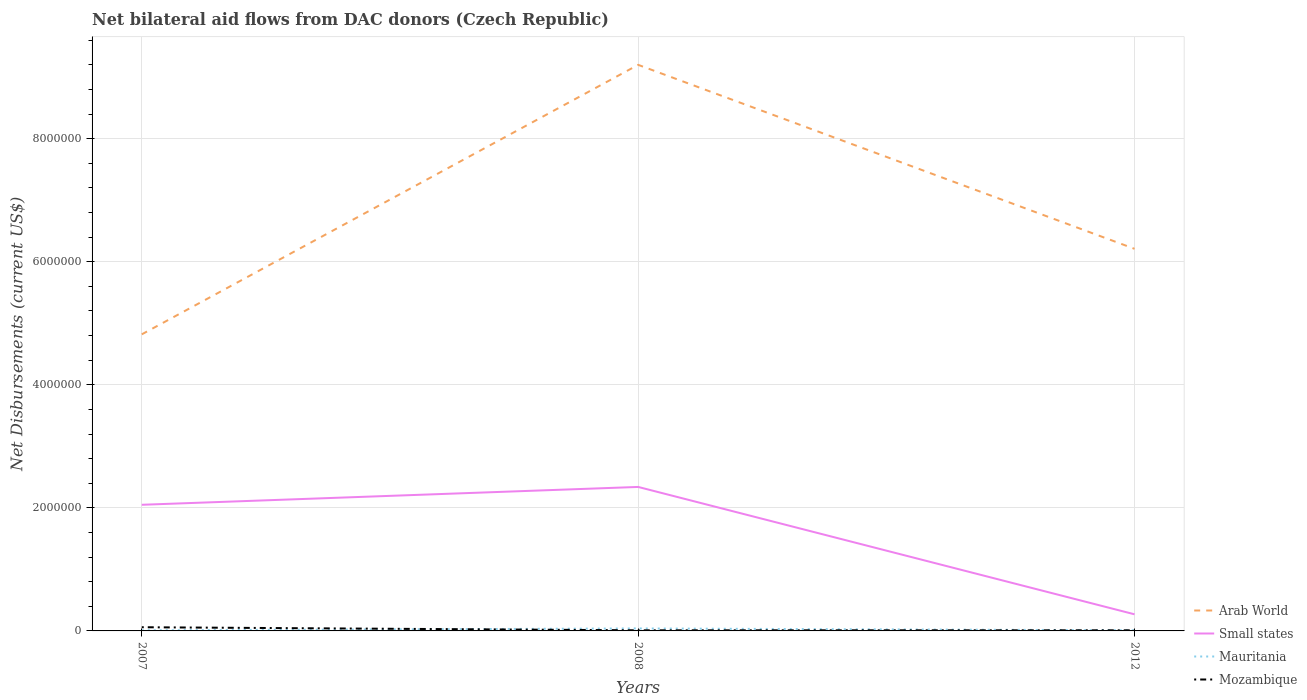How many different coloured lines are there?
Offer a very short reply. 4. Does the line corresponding to Mauritania intersect with the line corresponding to Mozambique?
Offer a very short reply. Yes. Is the number of lines equal to the number of legend labels?
Your answer should be compact. Yes. Across all years, what is the maximum net bilateral aid flows in Small states?
Your response must be concise. 2.70e+05. What is the difference between the highest and the second highest net bilateral aid flows in Mozambique?
Provide a short and direct response. 5.00e+04. What is the difference between the highest and the lowest net bilateral aid flows in Mauritania?
Your answer should be very brief. 1. What is the difference between two consecutive major ticks on the Y-axis?
Provide a succinct answer. 2.00e+06. Are the values on the major ticks of Y-axis written in scientific E-notation?
Your answer should be very brief. No. Does the graph contain grids?
Offer a very short reply. Yes. Where does the legend appear in the graph?
Offer a terse response. Bottom right. How many legend labels are there?
Offer a terse response. 4. What is the title of the graph?
Give a very brief answer. Net bilateral aid flows from DAC donors (Czech Republic). What is the label or title of the X-axis?
Offer a very short reply. Years. What is the label or title of the Y-axis?
Offer a terse response. Net Disbursements (current US$). What is the Net Disbursements (current US$) in Arab World in 2007?
Make the answer very short. 4.82e+06. What is the Net Disbursements (current US$) of Small states in 2007?
Provide a short and direct response. 2.05e+06. What is the Net Disbursements (current US$) of Mauritania in 2007?
Your answer should be very brief. 10000. What is the Net Disbursements (current US$) of Arab World in 2008?
Provide a short and direct response. 9.20e+06. What is the Net Disbursements (current US$) of Small states in 2008?
Keep it short and to the point. 2.34e+06. What is the Net Disbursements (current US$) of Mauritania in 2008?
Give a very brief answer. 4.00e+04. What is the Net Disbursements (current US$) in Arab World in 2012?
Provide a succinct answer. 6.21e+06. Across all years, what is the maximum Net Disbursements (current US$) in Arab World?
Your answer should be compact. 9.20e+06. Across all years, what is the maximum Net Disbursements (current US$) of Small states?
Keep it short and to the point. 2.34e+06. Across all years, what is the maximum Net Disbursements (current US$) in Mauritania?
Give a very brief answer. 4.00e+04. Across all years, what is the minimum Net Disbursements (current US$) in Arab World?
Ensure brevity in your answer.  4.82e+06. Across all years, what is the minimum Net Disbursements (current US$) of Small states?
Ensure brevity in your answer.  2.70e+05. Across all years, what is the minimum Net Disbursements (current US$) of Mauritania?
Give a very brief answer. 10000. What is the total Net Disbursements (current US$) of Arab World in the graph?
Give a very brief answer. 2.02e+07. What is the total Net Disbursements (current US$) in Small states in the graph?
Provide a succinct answer. 4.66e+06. What is the difference between the Net Disbursements (current US$) of Arab World in 2007 and that in 2008?
Your answer should be very brief. -4.38e+06. What is the difference between the Net Disbursements (current US$) of Arab World in 2007 and that in 2012?
Offer a very short reply. -1.39e+06. What is the difference between the Net Disbursements (current US$) of Small states in 2007 and that in 2012?
Give a very brief answer. 1.78e+06. What is the difference between the Net Disbursements (current US$) of Mauritania in 2007 and that in 2012?
Keep it short and to the point. 0. What is the difference between the Net Disbursements (current US$) of Arab World in 2008 and that in 2012?
Offer a terse response. 2.99e+06. What is the difference between the Net Disbursements (current US$) of Small states in 2008 and that in 2012?
Give a very brief answer. 2.07e+06. What is the difference between the Net Disbursements (current US$) in Mozambique in 2008 and that in 2012?
Give a very brief answer. 0. What is the difference between the Net Disbursements (current US$) of Arab World in 2007 and the Net Disbursements (current US$) of Small states in 2008?
Provide a short and direct response. 2.48e+06. What is the difference between the Net Disbursements (current US$) in Arab World in 2007 and the Net Disbursements (current US$) in Mauritania in 2008?
Provide a short and direct response. 4.78e+06. What is the difference between the Net Disbursements (current US$) of Arab World in 2007 and the Net Disbursements (current US$) of Mozambique in 2008?
Offer a very short reply. 4.81e+06. What is the difference between the Net Disbursements (current US$) of Small states in 2007 and the Net Disbursements (current US$) of Mauritania in 2008?
Give a very brief answer. 2.01e+06. What is the difference between the Net Disbursements (current US$) in Small states in 2007 and the Net Disbursements (current US$) in Mozambique in 2008?
Provide a succinct answer. 2.04e+06. What is the difference between the Net Disbursements (current US$) of Mauritania in 2007 and the Net Disbursements (current US$) of Mozambique in 2008?
Make the answer very short. 0. What is the difference between the Net Disbursements (current US$) of Arab World in 2007 and the Net Disbursements (current US$) of Small states in 2012?
Your answer should be compact. 4.55e+06. What is the difference between the Net Disbursements (current US$) in Arab World in 2007 and the Net Disbursements (current US$) in Mauritania in 2012?
Offer a terse response. 4.81e+06. What is the difference between the Net Disbursements (current US$) in Arab World in 2007 and the Net Disbursements (current US$) in Mozambique in 2012?
Provide a succinct answer. 4.81e+06. What is the difference between the Net Disbursements (current US$) in Small states in 2007 and the Net Disbursements (current US$) in Mauritania in 2012?
Give a very brief answer. 2.04e+06. What is the difference between the Net Disbursements (current US$) in Small states in 2007 and the Net Disbursements (current US$) in Mozambique in 2012?
Keep it short and to the point. 2.04e+06. What is the difference between the Net Disbursements (current US$) in Mauritania in 2007 and the Net Disbursements (current US$) in Mozambique in 2012?
Offer a terse response. 0. What is the difference between the Net Disbursements (current US$) in Arab World in 2008 and the Net Disbursements (current US$) in Small states in 2012?
Your answer should be very brief. 8.93e+06. What is the difference between the Net Disbursements (current US$) of Arab World in 2008 and the Net Disbursements (current US$) of Mauritania in 2012?
Provide a short and direct response. 9.19e+06. What is the difference between the Net Disbursements (current US$) in Arab World in 2008 and the Net Disbursements (current US$) in Mozambique in 2012?
Your answer should be very brief. 9.19e+06. What is the difference between the Net Disbursements (current US$) of Small states in 2008 and the Net Disbursements (current US$) of Mauritania in 2012?
Your answer should be very brief. 2.33e+06. What is the difference between the Net Disbursements (current US$) of Small states in 2008 and the Net Disbursements (current US$) of Mozambique in 2012?
Make the answer very short. 2.33e+06. What is the average Net Disbursements (current US$) in Arab World per year?
Keep it short and to the point. 6.74e+06. What is the average Net Disbursements (current US$) in Small states per year?
Offer a very short reply. 1.55e+06. What is the average Net Disbursements (current US$) of Mauritania per year?
Ensure brevity in your answer.  2.00e+04. What is the average Net Disbursements (current US$) in Mozambique per year?
Ensure brevity in your answer.  2.67e+04. In the year 2007, what is the difference between the Net Disbursements (current US$) of Arab World and Net Disbursements (current US$) of Small states?
Offer a terse response. 2.77e+06. In the year 2007, what is the difference between the Net Disbursements (current US$) in Arab World and Net Disbursements (current US$) in Mauritania?
Your answer should be very brief. 4.81e+06. In the year 2007, what is the difference between the Net Disbursements (current US$) in Arab World and Net Disbursements (current US$) in Mozambique?
Give a very brief answer. 4.76e+06. In the year 2007, what is the difference between the Net Disbursements (current US$) in Small states and Net Disbursements (current US$) in Mauritania?
Give a very brief answer. 2.04e+06. In the year 2007, what is the difference between the Net Disbursements (current US$) in Small states and Net Disbursements (current US$) in Mozambique?
Give a very brief answer. 1.99e+06. In the year 2007, what is the difference between the Net Disbursements (current US$) in Mauritania and Net Disbursements (current US$) in Mozambique?
Your response must be concise. -5.00e+04. In the year 2008, what is the difference between the Net Disbursements (current US$) of Arab World and Net Disbursements (current US$) of Small states?
Provide a succinct answer. 6.86e+06. In the year 2008, what is the difference between the Net Disbursements (current US$) in Arab World and Net Disbursements (current US$) in Mauritania?
Provide a succinct answer. 9.16e+06. In the year 2008, what is the difference between the Net Disbursements (current US$) in Arab World and Net Disbursements (current US$) in Mozambique?
Provide a short and direct response. 9.19e+06. In the year 2008, what is the difference between the Net Disbursements (current US$) in Small states and Net Disbursements (current US$) in Mauritania?
Provide a short and direct response. 2.30e+06. In the year 2008, what is the difference between the Net Disbursements (current US$) of Small states and Net Disbursements (current US$) of Mozambique?
Your response must be concise. 2.33e+06. In the year 2012, what is the difference between the Net Disbursements (current US$) in Arab World and Net Disbursements (current US$) in Small states?
Keep it short and to the point. 5.94e+06. In the year 2012, what is the difference between the Net Disbursements (current US$) of Arab World and Net Disbursements (current US$) of Mauritania?
Ensure brevity in your answer.  6.20e+06. In the year 2012, what is the difference between the Net Disbursements (current US$) of Arab World and Net Disbursements (current US$) of Mozambique?
Ensure brevity in your answer.  6.20e+06. In the year 2012, what is the difference between the Net Disbursements (current US$) in Small states and Net Disbursements (current US$) in Mauritania?
Give a very brief answer. 2.60e+05. In the year 2012, what is the difference between the Net Disbursements (current US$) of Small states and Net Disbursements (current US$) of Mozambique?
Your response must be concise. 2.60e+05. In the year 2012, what is the difference between the Net Disbursements (current US$) of Mauritania and Net Disbursements (current US$) of Mozambique?
Keep it short and to the point. 0. What is the ratio of the Net Disbursements (current US$) in Arab World in 2007 to that in 2008?
Provide a short and direct response. 0.52. What is the ratio of the Net Disbursements (current US$) of Small states in 2007 to that in 2008?
Provide a short and direct response. 0.88. What is the ratio of the Net Disbursements (current US$) in Mauritania in 2007 to that in 2008?
Give a very brief answer. 0.25. What is the ratio of the Net Disbursements (current US$) of Arab World in 2007 to that in 2012?
Offer a very short reply. 0.78. What is the ratio of the Net Disbursements (current US$) in Small states in 2007 to that in 2012?
Your response must be concise. 7.59. What is the ratio of the Net Disbursements (current US$) in Arab World in 2008 to that in 2012?
Your response must be concise. 1.48. What is the ratio of the Net Disbursements (current US$) of Small states in 2008 to that in 2012?
Offer a terse response. 8.67. What is the difference between the highest and the second highest Net Disbursements (current US$) of Arab World?
Your answer should be very brief. 2.99e+06. What is the difference between the highest and the second highest Net Disbursements (current US$) in Mauritania?
Provide a short and direct response. 3.00e+04. What is the difference between the highest and the second highest Net Disbursements (current US$) in Mozambique?
Keep it short and to the point. 5.00e+04. What is the difference between the highest and the lowest Net Disbursements (current US$) of Arab World?
Offer a very short reply. 4.38e+06. What is the difference between the highest and the lowest Net Disbursements (current US$) of Small states?
Your answer should be compact. 2.07e+06. What is the difference between the highest and the lowest Net Disbursements (current US$) in Mauritania?
Make the answer very short. 3.00e+04. 